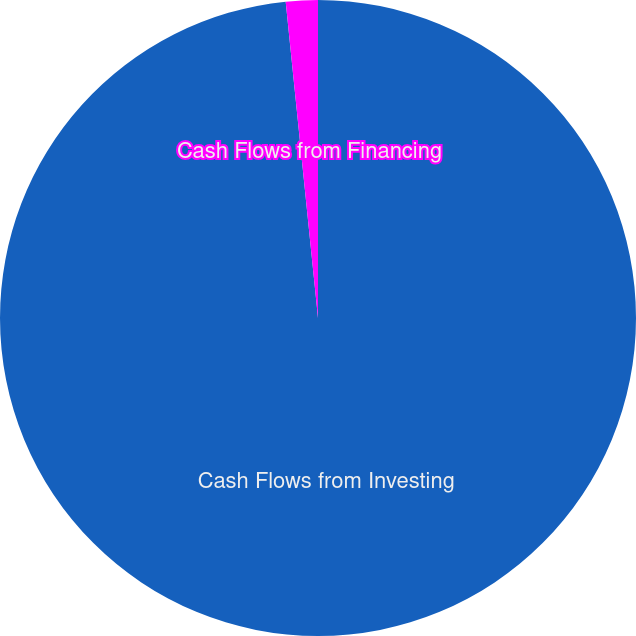Convert chart to OTSL. <chart><loc_0><loc_0><loc_500><loc_500><pie_chart><fcel>Cash Flows from Investing<fcel>Cash Flows from Financing<nl><fcel>98.38%<fcel>1.62%<nl></chart> 